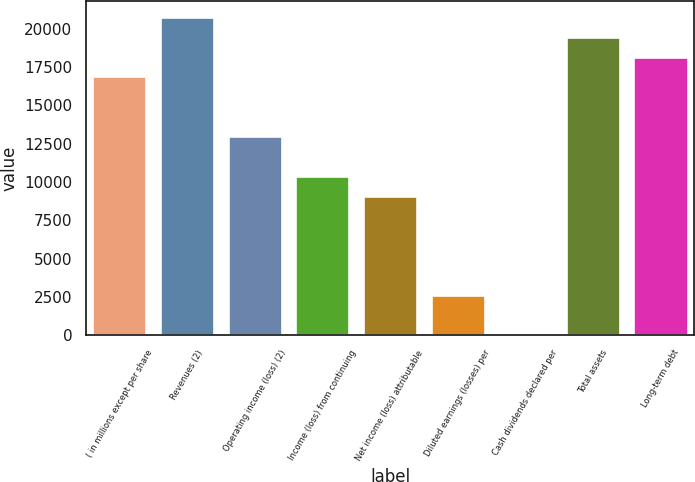<chart> <loc_0><loc_0><loc_500><loc_500><bar_chart><fcel>( in millions except per share<fcel>Revenues (2)<fcel>Operating income (loss) (2)<fcel>Income (loss) from continuing<fcel>Net income (loss) attributable<fcel>Diluted earnings (losses) per<fcel>Cash dividends declared per<fcel>Total assets<fcel>Long-term debt<nl><fcel>16886.9<fcel>20783.8<fcel>12990<fcel>10392<fcel>9093.07<fcel>2598.22<fcel>0.28<fcel>19484.8<fcel>18185.9<nl></chart> 